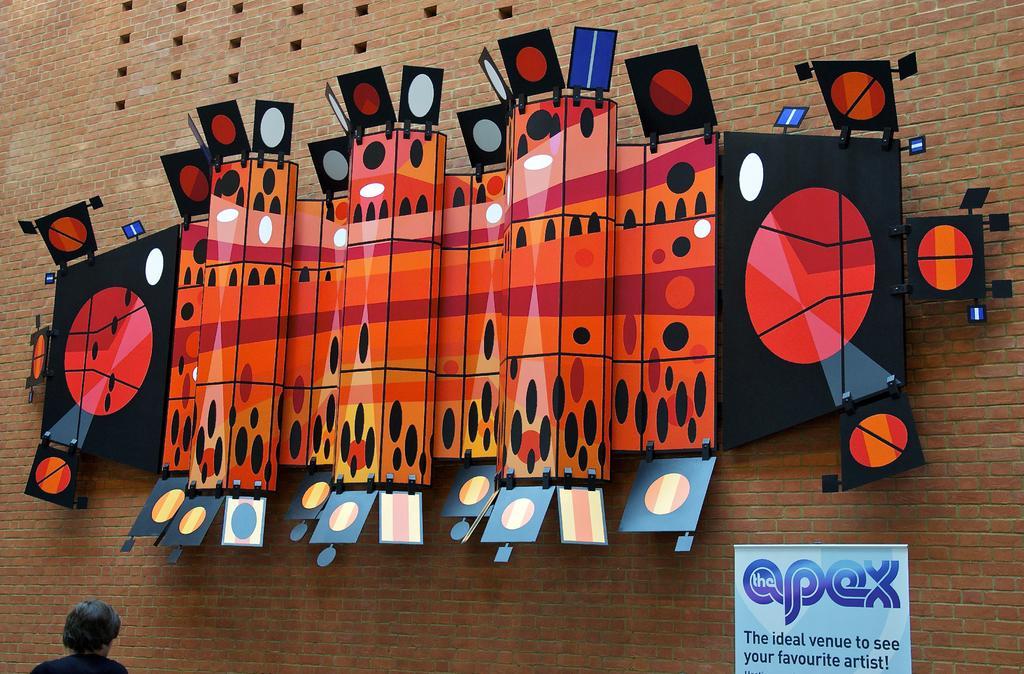Could you give a brief overview of what you see in this image? In this image we can see a person, in front of him there are boards on the wall, also we can see a banner with text on it. 